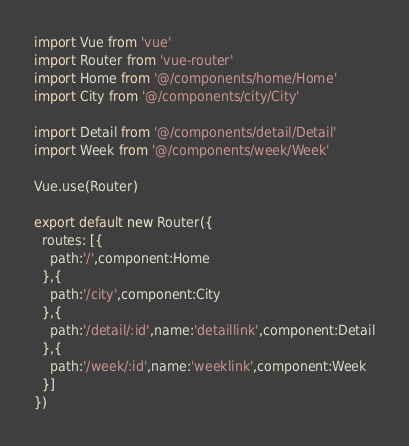Convert code to text. <code><loc_0><loc_0><loc_500><loc_500><_JavaScript_>import Vue from 'vue'
import Router from 'vue-router'
import Home from '@/components/home/Home'
import City from '@/components/city/City'

import Detail from '@/components/detail/Detail'
import Week from '@/components/week/Week'

Vue.use(Router)

export default new Router({
  routes: [{
    path:'/',component:Home
  },{
    path:'/city',component:City
  },{
    path:'/detail/:id',name:'detaillink',component:Detail
  },{
    path:'/week/:id',name:'weeklink',component:Week
  }]
})
</code> 